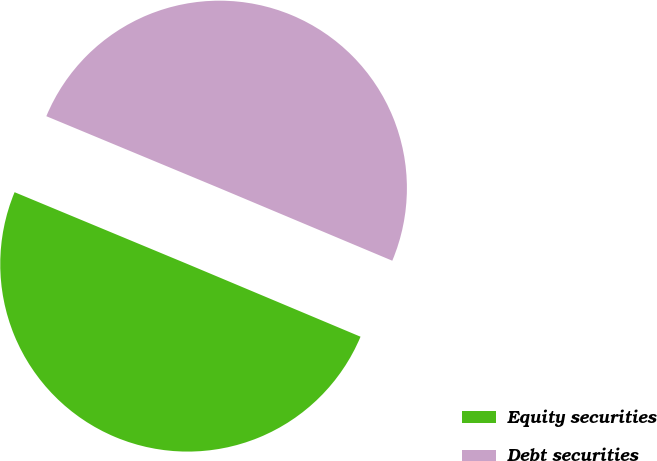<chart> <loc_0><loc_0><loc_500><loc_500><pie_chart><fcel>Equity securities<fcel>Debt securities<nl><fcel>49.94%<fcel>50.06%<nl></chart> 